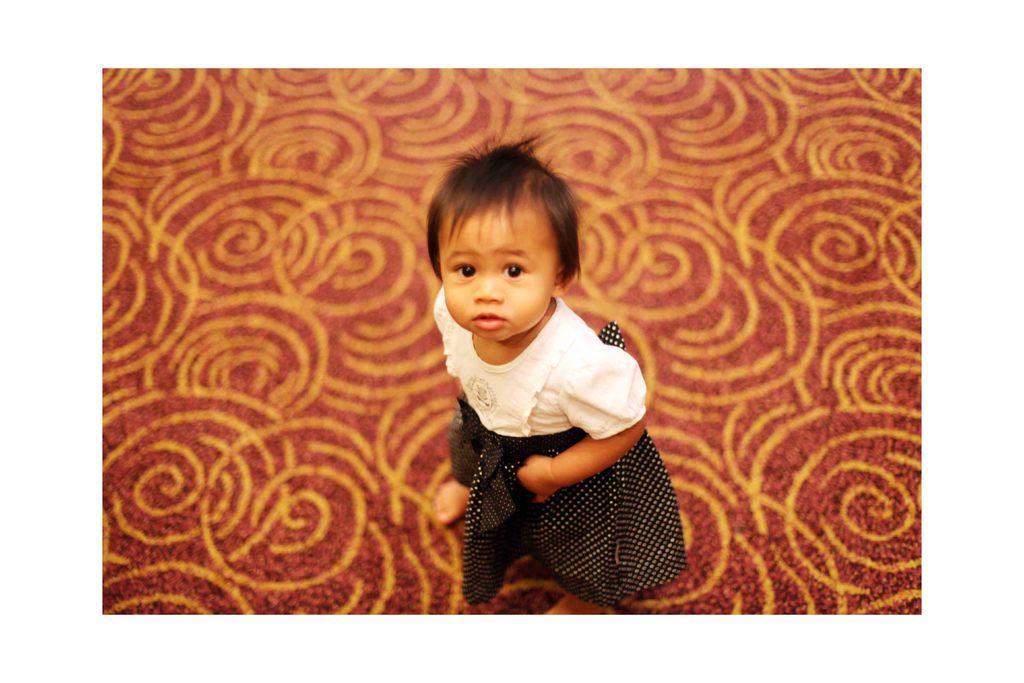Could you give a brief overview of what you see in this image? In this image, we can see a kid standing. We can also see the ground. 